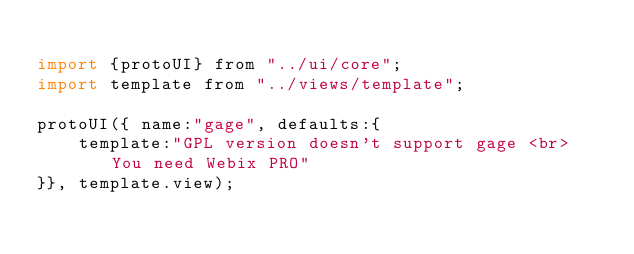Convert code to text. <code><loc_0><loc_0><loc_500><loc_500><_JavaScript_>
import {protoUI} from "../ui/core";
import template from "../views/template";

protoUI({ name:"gage", defaults:{
	template:"GPL version doesn't support gage <br> You need Webix PRO"
}}, template.view);</code> 